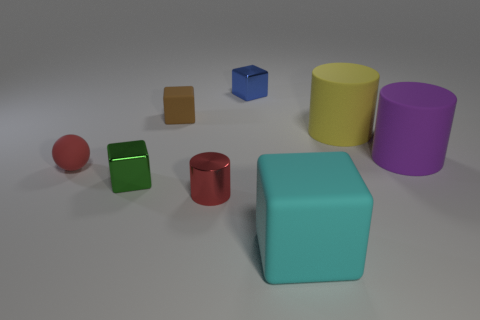Add 2 big cyan metal spheres. How many objects exist? 10 Subtract all large yellow rubber cylinders. How many cylinders are left? 2 Subtract all yellow cylinders. How many cylinders are left? 2 Subtract 1 cylinders. How many cylinders are left? 2 Subtract all balls. How many objects are left? 7 Subtract all yellow cylinders. Subtract all red balls. How many cylinders are left? 2 Add 2 small shiny blocks. How many small shiny blocks are left? 4 Add 1 purple rubber blocks. How many purple rubber blocks exist? 1 Subtract 0 yellow spheres. How many objects are left? 8 Subtract all tiny red spheres. Subtract all yellow matte cylinders. How many objects are left? 6 